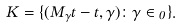Convert formula to latex. <formula><loc_0><loc_0><loc_500><loc_500>K = \{ ( M _ { \gamma } t - t , \gamma ) \colon \gamma \in \Gamma _ { 0 } \} .</formula> 